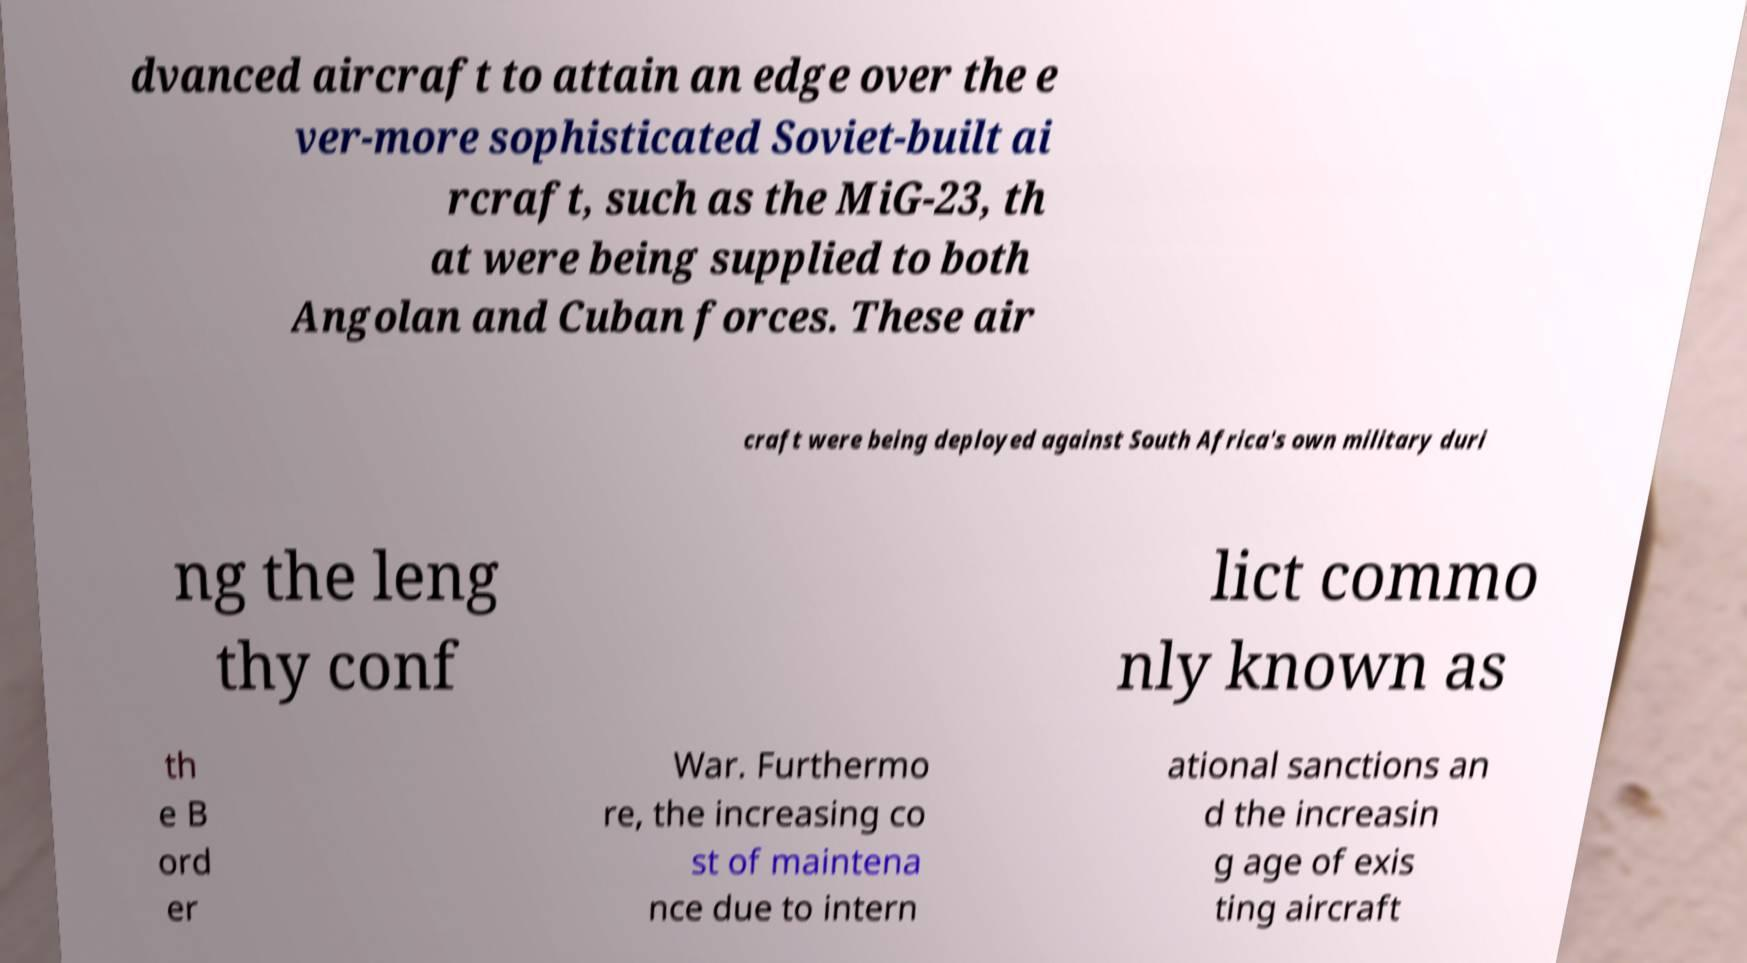Please identify and transcribe the text found in this image. dvanced aircraft to attain an edge over the e ver-more sophisticated Soviet-built ai rcraft, such as the MiG-23, th at were being supplied to both Angolan and Cuban forces. These air craft were being deployed against South Africa's own military duri ng the leng thy conf lict commo nly known as th e B ord er War. Furthermo re, the increasing co st of maintena nce due to intern ational sanctions an d the increasin g age of exis ting aircraft 